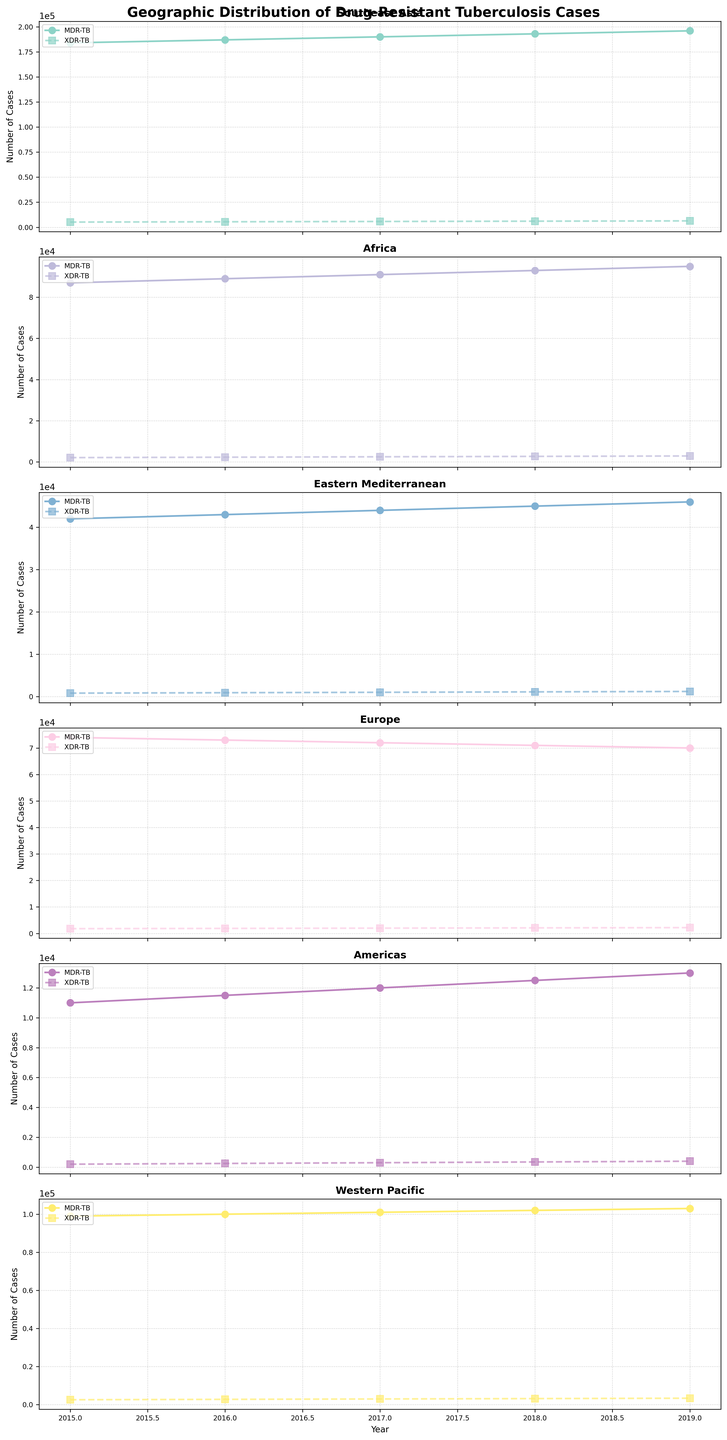Which region had the highest number of MDR-TB cases in 2019? By looking at the top data points labeled 'MDR-TB' for each region in 2019, we note that Southeast Asia shows the highest value.
Answer: Southeast Asia Which region showed the least number of XDR-TB cases in 2017? By comparing the data points labeled 'XDR-TB' in 2017 across all regions, the Americas has the smallest number of cases.
Answer: Americas How did the number of MDR-TB cases change in Southeast Asia from 2015 to 2019? By observing the trend line for Southeast Asia labeled 'MDR-TB', the MDR-TB cases increased from 184,000 in 2015 to 196,000 in 2019.
Answer: Increased What's the difference between MDR-TB and XDR-TB cases in Africa in 2018? Refer to the values for Africa in 2018: MDR-TB is 93,000 and XDR-TB is 2,700. The difference is 93,000 - 2,700 = 90,300.
Answer: 90,300 In which region did the number of XDR-TB cases increase the most from 2015 to 2019? Compare the increase in XDR-TB cases from 2015 to 2019 for each region. Southeast Asia increased from 5,200 to 6,400, the highest among all regions.
Answer: Southeast Asia Which region saw a declining trend in MDR-TB cases from 2015 to 2019? Check the trend lines for MDR-TB and see which one is decreasing. Europe shows a decline from 74,000 in 2015 to 70,000 in 2019.
Answer: Europe What's the average number of XDR-TB cases in the Western Pacific from 2015 to 2019? The XDR-TB cases for these years in the Western Pacific are 2500, 2700, 2900, 3100, and 3300. Adding these gives 14,500, and dividing by 5 gives the average: 2,900.
Answer: 2,900 Compare the change in MDR-TB cases between 2017 and 2018 for Southeast Asia and Africa. Which one had a larger increase? In Southeast Asia, MDR-TB cases went from 190,000 to 193,000, an increase of 3,000. In Africa, cases went from 91,000 to 93,000, an increase of 2,000. Southeast Asia had a larger increase.
Answer: Southeast Asia Which region had the most stable number of MDR-TB cases over the years? By observing the MDR-TB trend lines, the Americas show the smallest changes compared to other regions, indicating stability.
Answer: Americas 